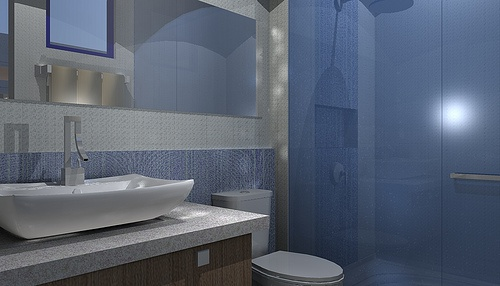Describe the objects in this image and their specific colors. I can see sink in gray, darkgray, and lightgray tones and toilet in gray tones in this image. 